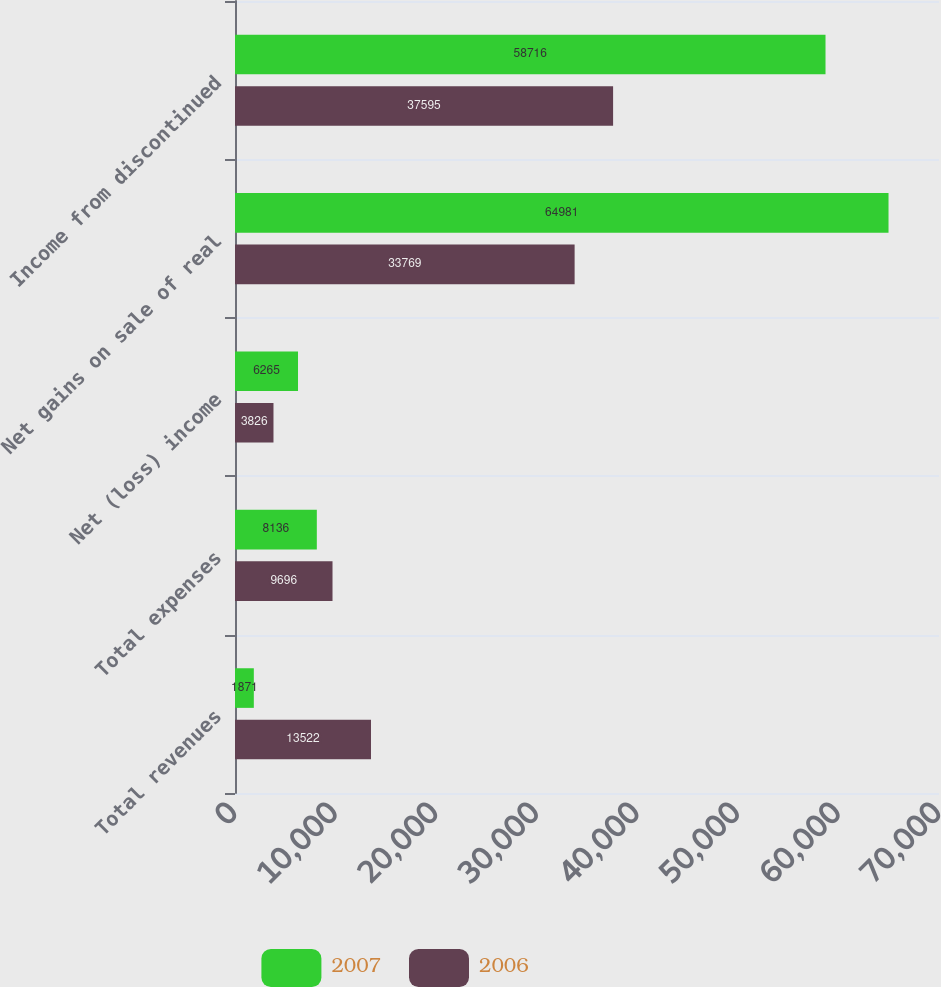Convert chart to OTSL. <chart><loc_0><loc_0><loc_500><loc_500><stacked_bar_chart><ecel><fcel>Total revenues<fcel>Total expenses<fcel>Net (loss) income<fcel>Net gains on sale of real<fcel>Income from discontinued<nl><fcel>2007<fcel>1871<fcel>8136<fcel>6265<fcel>64981<fcel>58716<nl><fcel>2006<fcel>13522<fcel>9696<fcel>3826<fcel>33769<fcel>37595<nl></chart> 